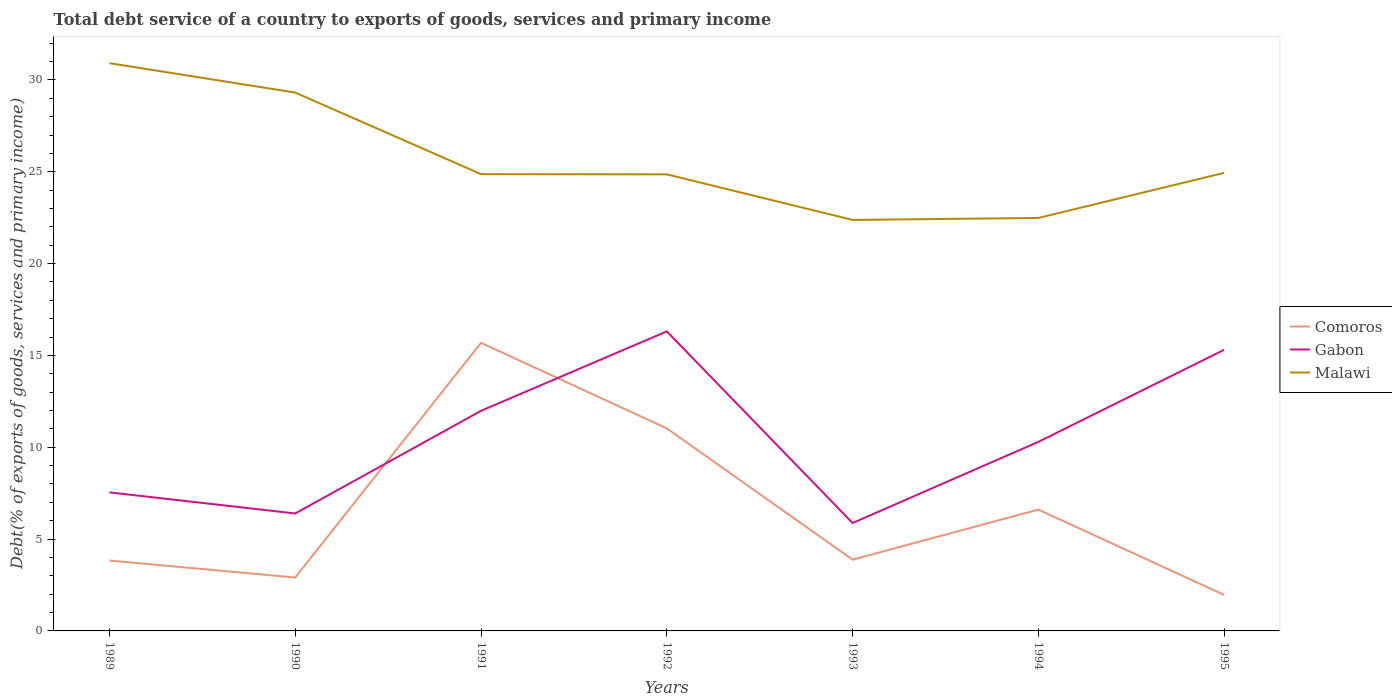Does the line corresponding to Gabon intersect with the line corresponding to Comoros?
Your response must be concise. Yes. Across all years, what is the maximum total debt service in Malawi?
Make the answer very short. 22.38. What is the total total debt service in Malawi in the graph?
Offer a terse response. 6.83. What is the difference between the highest and the second highest total debt service in Malawi?
Offer a very short reply. 8.54. Is the total debt service in Gabon strictly greater than the total debt service in Malawi over the years?
Provide a succinct answer. Yes. How many years are there in the graph?
Your response must be concise. 7. What is the difference between two consecutive major ticks on the Y-axis?
Ensure brevity in your answer.  5. Are the values on the major ticks of Y-axis written in scientific E-notation?
Ensure brevity in your answer.  No. Where does the legend appear in the graph?
Provide a short and direct response. Center right. What is the title of the graph?
Your answer should be very brief. Total debt service of a country to exports of goods, services and primary income. What is the label or title of the X-axis?
Offer a terse response. Years. What is the label or title of the Y-axis?
Your response must be concise. Debt(% of exports of goods, services and primary income). What is the Debt(% of exports of goods, services and primary income) in Comoros in 1989?
Give a very brief answer. 3.83. What is the Debt(% of exports of goods, services and primary income) of Gabon in 1989?
Ensure brevity in your answer.  7.54. What is the Debt(% of exports of goods, services and primary income) in Malawi in 1989?
Your answer should be very brief. 30.91. What is the Debt(% of exports of goods, services and primary income) in Comoros in 1990?
Your answer should be very brief. 2.91. What is the Debt(% of exports of goods, services and primary income) in Gabon in 1990?
Keep it short and to the point. 6.39. What is the Debt(% of exports of goods, services and primary income) in Malawi in 1990?
Provide a succinct answer. 29.31. What is the Debt(% of exports of goods, services and primary income) in Comoros in 1991?
Keep it short and to the point. 15.69. What is the Debt(% of exports of goods, services and primary income) of Gabon in 1991?
Keep it short and to the point. 11.98. What is the Debt(% of exports of goods, services and primary income) in Malawi in 1991?
Make the answer very short. 24.87. What is the Debt(% of exports of goods, services and primary income) of Comoros in 1992?
Your answer should be very brief. 11.03. What is the Debt(% of exports of goods, services and primary income) in Gabon in 1992?
Your answer should be very brief. 16.31. What is the Debt(% of exports of goods, services and primary income) of Malawi in 1992?
Provide a succinct answer. 24.86. What is the Debt(% of exports of goods, services and primary income) in Comoros in 1993?
Provide a succinct answer. 3.88. What is the Debt(% of exports of goods, services and primary income) of Gabon in 1993?
Your answer should be compact. 5.87. What is the Debt(% of exports of goods, services and primary income) in Malawi in 1993?
Offer a very short reply. 22.38. What is the Debt(% of exports of goods, services and primary income) of Comoros in 1994?
Provide a short and direct response. 6.61. What is the Debt(% of exports of goods, services and primary income) of Gabon in 1994?
Your answer should be compact. 10.29. What is the Debt(% of exports of goods, services and primary income) of Malawi in 1994?
Ensure brevity in your answer.  22.49. What is the Debt(% of exports of goods, services and primary income) in Comoros in 1995?
Your answer should be compact. 1.96. What is the Debt(% of exports of goods, services and primary income) in Gabon in 1995?
Ensure brevity in your answer.  15.31. What is the Debt(% of exports of goods, services and primary income) in Malawi in 1995?
Your response must be concise. 24.94. Across all years, what is the maximum Debt(% of exports of goods, services and primary income) in Comoros?
Give a very brief answer. 15.69. Across all years, what is the maximum Debt(% of exports of goods, services and primary income) of Gabon?
Ensure brevity in your answer.  16.31. Across all years, what is the maximum Debt(% of exports of goods, services and primary income) of Malawi?
Keep it short and to the point. 30.91. Across all years, what is the minimum Debt(% of exports of goods, services and primary income) in Comoros?
Provide a succinct answer. 1.96. Across all years, what is the minimum Debt(% of exports of goods, services and primary income) of Gabon?
Your answer should be compact. 5.87. Across all years, what is the minimum Debt(% of exports of goods, services and primary income) of Malawi?
Offer a very short reply. 22.38. What is the total Debt(% of exports of goods, services and primary income) in Comoros in the graph?
Your response must be concise. 45.9. What is the total Debt(% of exports of goods, services and primary income) in Gabon in the graph?
Ensure brevity in your answer.  73.71. What is the total Debt(% of exports of goods, services and primary income) of Malawi in the graph?
Provide a succinct answer. 179.76. What is the difference between the Debt(% of exports of goods, services and primary income) of Comoros in 1989 and that in 1990?
Offer a very short reply. 0.93. What is the difference between the Debt(% of exports of goods, services and primary income) in Gabon in 1989 and that in 1990?
Provide a succinct answer. 1.15. What is the difference between the Debt(% of exports of goods, services and primary income) of Malawi in 1989 and that in 1990?
Ensure brevity in your answer.  1.6. What is the difference between the Debt(% of exports of goods, services and primary income) of Comoros in 1989 and that in 1991?
Your answer should be compact. -11.85. What is the difference between the Debt(% of exports of goods, services and primary income) of Gabon in 1989 and that in 1991?
Your response must be concise. -4.44. What is the difference between the Debt(% of exports of goods, services and primary income) in Malawi in 1989 and that in 1991?
Your response must be concise. 6.04. What is the difference between the Debt(% of exports of goods, services and primary income) of Comoros in 1989 and that in 1992?
Offer a very short reply. -7.2. What is the difference between the Debt(% of exports of goods, services and primary income) of Gabon in 1989 and that in 1992?
Your answer should be very brief. -8.77. What is the difference between the Debt(% of exports of goods, services and primary income) of Malawi in 1989 and that in 1992?
Make the answer very short. 6.05. What is the difference between the Debt(% of exports of goods, services and primary income) of Comoros in 1989 and that in 1993?
Your response must be concise. -0.05. What is the difference between the Debt(% of exports of goods, services and primary income) of Gabon in 1989 and that in 1993?
Keep it short and to the point. 1.67. What is the difference between the Debt(% of exports of goods, services and primary income) of Malawi in 1989 and that in 1993?
Keep it short and to the point. 8.54. What is the difference between the Debt(% of exports of goods, services and primary income) of Comoros in 1989 and that in 1994?
Provide a short and direct response. -2.77. What is the difference between the Debt(% of exports of goods, services and primary income) of Gabon in 1989 and that in 1994?
Provide a succinct answer. -2.75. What is the difference between the Debt(% of exports of goods, services and primary income) of Malawi in 1989 and that in 1994?
Provide a succinct answer. 8.43. What is the difference between the Debt(% of exports of goods, services and primary income) in Comoros in 1989 and that in 1995?
Give a very brief answer. 1.87. What is the difference between the Debt(% of exports of goods, services and primary income) in Gabon in 1989 and that in 1995?
Make the answer very short. -7.76. What is the difference between the Debt(% of exports of goods, services and primary income) of Malawi in 1989 and that in 1995?
Keep it short and to the point. 5.97. What is the difference between the Debt(% of exports of goods, services and primary income) of Comoros in 1990 and that in 1991?
Keep it short and to the point. -12.78. What is the difference between the Debt(% of exports of goods, services and primary income) of Gabon in 1990 and that in 1991?
Ensure brevity in your answer.  -5.59. What is the difference between the Debt(% of exports of goods, services and primary income) of Malawi in 1990 and that in 1991?
Offer a very short reply. 4.44. What is the difference between the Debt(% of exports of goods, services and primary income) of Comoros in 1990 and that in 1992?
Your response must be concise. -8.12. What is the difference between the Debt(% of exports of goods, services and primary income) of Gabon in 1990 and that in 1992?
Your answer should be very brief. -9.92. What is the difference between the Debt(% of exports of goods, services and primary income) in Malawi in 1990 and that in 1992?
Give a very brief answer. 4.45. What is the difference between the Debt(% of exports of goods, services and primary income) in Comoros in 1990 and that in 1993?
Your answer should be compact. -0.97. What is the difference between the Debt(% of exports of goods, services and primary income) of Gabon in 1990 and that in 1993?
Your response must be concise. 0.52. What is the difference between the Debt(% of exports of goods, services and primary income) in Malawi in 1990 and that in 1993?
Offer a terse response. 6.93. What is the difference between the Debt(% of exports of goods, services and primary income) in Comoros in 1990 and that in 1994?
Provide a short and direct response. -3.7. What is the difference between the Debt(% of exports of goods, services and primary income) of Gabon in 1990 and that in 1994?
Your answer should be compact. -3.9. What is the difference between the Debt(% of exports of goods, services and primary income) in Malawi in 1990 and that in 1994?
Give a very brief answer. 6.83. What is the difference between the Debt(% of exports of goods, services and primary income) in Comoros in 1990 and that in 1995?
Provide a short and direct response. 0.95. What is the difference between the Debt(% of exports of goods, services and primary income) in Gabon in 1990 and that in 1995?
Give a very brief answer. -8.91. What is the difference between the Debt(% of exports of goods, services and primary income) of Malawi in 1990 and that in 1995?
Give a very brief answer. 4.37. What is the difference between the Debt(% of exports of goods, services and primary income) in Comoros in 1991 and that in 1992?
Provide a short and direct response. 4.66. What is the difference between the Debt(% of exports of goods, services and primary income) of Gabon in 1991 and that in 1992?
Provide a succinct answer. -4.33. What is the difference between the Debt(% of exports of goods, services and primary income) in Malawi in 1991 and that in 1992?
Provide a succinct answer. 0.01. What is the difference between the Debt(% of exports of goods, services and primary income) in Comoros in 1991 and that in 1993?
Your response must be concise. 11.81. What is the difference between the Debt(% of exports of goods, services and primary income) in Gabon in 1991 and that in 1993?
Your response must be concise. 6.11. What is the difference between the Debt(% of exports of goods, services and primary income) of Malawi in 1991 and that in 1993?
Offer a very short reply. 2.49. What is the difference between the Debt(% of exports of goods, services and primary income) of Comoros in 1991 and that in 1994?
Your answer should be compact. 9.08. What is the difference between the Debt(% of exports of goods, services and primary income) in Gabon in 1991 and that in 1994?
Your answer should be very brief. 1.69. What is the difference between the Debt(% of exports of goods, services and primary income) in Malawi in 1991 and that in 1994?
Make the answer very short. 2.39. What is the difference between the Debt(% of exports of goods, services and primary income) in Comoros in 1991 and that in 1995?
Give a very brief answer. 13.73. What is the difference between the Debt(% of exports of goods, services and primary income) in Gabon in 1991 and that in 1995?
Your answer should be compact. -3.32. What is the difference between the Debt(% of exports of goods, services and primary income) in Malawi in 1991 and that in 1995?
Offer a very short reply. -0.07. What is the difference between the Debt(% of exports of goods, services and primary income) in Comoros in 1992 and that in 1993?
Your answer should be compact. 7.15. What is the difference between the Debt(% of exports of goods, services and primary income) of Gabon in 1992 and that in 1993?
Offer a terse response. 10.44. What is the difference between the Debt(% of exports of goods, services and primary income) in Malawi in 1992 and that in 1993?
Provide a succinct answer. 2.48. What is the difference between the Debt(% of exports of goods, services and primary income) in Comoros in 1992 and that in 1994?
Ensure brevity in your answer.  4.42. What is the difference between the Debt(% of exports of goods, services and primary income) of Gabon in 1992 and that in 1994?
Provide a succinct answer. 6.02. What is the difference between the Debt(% of exports of goods, services and primary income) of Malawi in 1992 and that in 1994?
Your answer should be compact. 2.37. What is the difference between the Debt(% of exports of goods, services and primary income) in Comoros in 1992 and that in 1995?
Provide a succinct answer. 9.07. What is the difference between the Debt(% of exports of goods, services and primary income) of Malawi in 1992 and that in 1995?
Provide a succinct answer. -0.08. What is the difference between the Debt(% of exports of goods, services and primary income) in Comoros in 1993 and that in 1994?
Your answer should be compact. -2.73. What is the difference between the Debt(% of exports of goods, services and primary income) of Gabon in 1993 and that in 1994?
Your response must be concise. -4.42. What is the difference between the Debt(% of exports of goods, services and primary income) in Malawi in 1993 and that in 1994?
Your answer should be very brief. -0.11. What is the difference between the Debt(% of exports of goods, services and primary income) in Comoros in 1993 and that in 1995?
Your response must be concise. 1.92. What is the difference between the Debt(% of exports of goods, services and primary income) in Gabon in 1993 and that in 1995?
Provide a short and direct response. -9.43. What is the difference between the Debt(% of exports of goods, services and primary income) in Malawi in 1993 and that in 1995?
Your answer should be compact. -2.56. What is the difference between the Debt(% of exports of goods, services and primary income) of Comoros in 1994 and that in 1995?
Give a very brief answer. 4.65. What is the difference between the Debt(% of exports of goods, services and primary income) of Gabon in 1994 and that in 1995?
Make the answer very short. -5.01. What is the difference between the Debt(% of exports of goods, services and primary income) in Malawi in 1994 and that in 1995?
Make the answer very short. -2.45. What is the difference between the Debt(% of exports of goods, services and primary income) in Comoros in 1989 and the Debt(% of exports of goods, services and primary income) in Gabon in 1990?
Your answer should be compact. -2.56. What is the difference between the Debt(% of exports of goods, services and primary income) of Comoros in 1989 and the Debt(% of exports of goods, services and primary income) of Malawi in 1990?
Provide a succinct answer. -25.48. What is the difference between the Debt(% of exports of goods, services and primary income) of Gabon in 1989 and the Debt(% of exports of goods, services and primary income) of Malawi in 1990?
Offer a terse response. -21.77. What is the difference between the Debt(% of exports of goods, services and primary income) of Comoros in 1989 and the Debt(% of exports of goods, services and primary income) of Gabon in 1991?
Provide a succinct answer. -8.15. What is the difference between the Debt(% of exports of goods, services and primary income) of Comoros in 1989 and the Debt(% of exports of goods, services and primary income) of Malawi in 1991?
Offer a terse response. -21.04. What is the difference between the Debt(% of exports of goods, services and primary income) in Gabon in 1989 and the Debt(% of exports of goods, services and primary income) in Malawi in 1991?
Provide a succinct answer. -17.33. What is the difference between the Debt(% of exports of goods, services and primary income) of Comoros in 1989 and the Debt(% of exports of goods, services and primary income) of Gabon in 1992?
Ensure brevity in your answer.  -12.48. What is the difference between the Debt(% of exports of goods, services and primary income) in Comoros in 1989 and the Debt(% of exports of goods, services and primary income) in Malawi in 1992?
Your answer should be compact. -21.03. What is the difference between the Debt(% of exports of goods, services and primary income) in Gabon in 1989 and the Debt(% of exports of goods, services and primary income) in Malawi in 1992?
Provide a succinct answer. -17.32. What is the difference between the Debt(% of exports of goods, services and primary income) of Comoros in 1989 and the Debt(% of exports of goods, services and primary income) of Gabon in 1993?
Make the answer very short. -2.04. What is the difference between the Debt(% of exports of goods, services and primary income) of Comoros in 1989 and the Debt(% of exports of goods, services and primary income) of Malawi in 1993?
Make the answer very short. -18.55. What is the difference between the Debt(% of exports of goods, services and primary income) of Gabon in 1989 and the Debt(% of exports of goods, services and primary income) of Malawi in 1993?
Ensure brevity in your answer.  -14.83. What is the difference between the Debt(% of exports of goods, services and primary income) in Comoros in 1989 and the Debt(% of exports of goods, services and primary income) in Gabon in 1994?
Provide a succinct answer. -6.46. What is the difference between the Debt(% of exports of goods, services and primary income) of Comoros in 1989 and the Debt(% of exports of goods, services and primary income) of Malawi in 1994?
Keep it short and to the point. -18.65. What is the difference between the Debt(% of exports of goods, services and primary income) in Gabon in 1989 and the Debt(% of exports of goods, services and primary income) in Malawi in 1994?
Your answer should be compact. -14.94. What is the difference between the Debt(% of exports of goods, services and primary income) in Comoros in 1989 and the Debt(% of exports of goods, services and primary income) in Gabon in 1995?
Provide a short and direct response. -11.48. What is the difference between the Debt(% of exports of goods, services and primary income) of Comoros in 1989 and the Debt(% of exports of goods, services and primary income) of Malawi in 1995?
Keep it short and to the point. -21.11. What is the difference between the Debt(% of exports of goods, services and primary income) of Gabon in 1989 and the Debt(% of exports of goods, services and primary income) of Malawi in 1995?
Make the answer very short. -17.4. What is the difference between the Debt(% of exports of goods, services and primary income) of Comoros in 1990 and the Debt(% of exports of goods, services and primary income) of Gabon in 1991?
Your answer should be very brief. -9.08. What is the difference between the Debt(% of exports of goods, services and primary income) of Comoros in 1990 and the Debt(% of exports of goods, services and primary income) of Malawi in 1991?
Your answer should be compact. -21.96. What is the difference between the Debt(% of exports of goods, services and primary income) in Gabon in 1990 and the Debt(% of exports of goods, services and primary income) in Malawi in 1991?
Give a very brief answer. -18.48. What is the difference between the Debt(% of exports of goods, services and primary income) in Comoros in 1990 and the Debt(% of exports of goods, services and primary income) in Gabon in 1992?
Offer a terse response. -13.4. What is the difference between the Debt(% of exports of goods, services and primary income) in Comoros in 1990 and the Debt(% of exports of goods, services and primary income) in Malawi in 1992?
Offer a very short reply. -21.95. What is the difference between the Debt(% of exports of goods, services and primary income) of Gabon in 1990 and the Debt(% of exports of goods, services and primary income) of Malawi in 1992?
Provide a succinct answer. -18.46. What is the difference between the Debt(% of exports of goods, services and primary income) of Comoros in 1990 and the Debt(% of exports of goods, services and primary income) of Gabon in 1993?
Provide a short and direct response. -2.97. What is the difference between the Debt(% of exports of goods, services and primary income) of Comoros in 1990 and the Debt(% of exports of goods, services and primary income) of Malawi in 1993?
Provide a succinct answer. -19.47. What is the difference between the Debt(% of exports of goods, services and primary income) in Gabon in 1990 and the Debt(% of exports of goods, services and primary income) in Malawi in 1993?
Provide a short and direct response. -15.98. What is the difference between the Debt(% of exports of goods, services and primary income) in Comoros in 1990 and the Debt(% of exports of goods, services and primary income) in Gabon in 1994?
Your response must be concise. -7.39. What is the difference between the Debt(% of exports of goods, services and primary income) of Comoros in 1990 and the Debt(% of exports of goods, services and primary income) of Malawi in 1994?
Ensure brevity in your answer.  -19.58. What is the difference between the Debt(% of exports of goods, services and primary income) of Gabon in 1990 and the Debt(% of exports of goods, services and primary income) of Malawi in 1994?
Your answer should be compact. -16.09. What is the difference between the Debt(% of exports of goods, services and primary income) in Comoros in 1990 and the Debt(% of exports of goods, services and primary income) in Gabon in 1995?
Your answer should be very brief. -12.4. What is the difference between the Debt(% of exports of goods, services and primary income) in Comoros in 1990 and the Debt(% of exports of goods, services and primary income) in Malawi in 1995?
Provide a short and direct response. -22.03. What is the difference between the Debt(% of exports of goods, services and primary income) in Gabon in 1990 and the Debt(% of exports of goods, services and primary income) in Malawi in 1995?
Your answer should be very brief. -18.55. What is the difference between the Debt(% of exports of goods, services and primary income) of Comoros in 1991 and the Debt(% of exports of goods, services and primary income) of Gabon in 1992?
Your answer should be very brief. -0.62. What is the difference between the Debt(% of exports of goods, services and primary income) of Comoros in 1991 and the Debt(% of exports of goods, services and primary income) of Malawi in 1992?
Keep it short and to the point. -9.17. What is the difference between the Debt(% of exports of goods, services and primary income) in Gabon in 1991 and the Debt(% of exports of goods, services and primary income) in Malawi in 1992?
Ensure brevity in your answer.  -12.88. What is the difference between the Debt(% of exports of goods, services and primary income) of Comoros in 1991 and the Debt(% of exports of goods, services and primary income) of Gabon in 1993?
Keep it short and to the point. 9.81. What is the difference between the Debt(% of exports of goods, services and primary income) of Comoros in 1991 and the Debt(% of exports of goods, services and primary income) of Malawi in 1993?
Offer a terse response. -6.69. What is the difference between the Debt(% of exports of goods, services and primary income) in Gabon in 1991 and the Debt(% of exports of goods, services and primary income) in Malawi in 1993?
Provide a succinct answer. -10.39. What is the difference between the Debt(% of exports of goods, services and primary income) in Comoros in 1991 and the Debt(% of exports of goods, services and primary income) in Gabon in 1994?
Offer a very short reply. 5.39. What is the difference between the Debt(% of exports of goods, services and primary income) in Comoros in 1991 and the Debt(% of exports of goods, services and primary income) in Malawi in 1994?
Give a very brief answer. -6.8. What is the difference between the Debt(% of exports of goods, services and primary income) of Gabon in 1991 and the Debt(% of exports of goods, services and primary income) of Malawi in 1994?
Offer a terse response. -10.5. What is the difference between the Debt(% of exports of goods, services and primary income) in Comoros in 1991 and the Debt(% of exports of goods, services and primary income) in Gabon in 1995?
Offer a terse response. 0.38. What is the difference between the Debt(% of exports of goods, services and primary income) of Comoros in 1991 and the Debt(% of exports of goods, services and primary income) of Malawi in 1995?
Offer a terse response. -9.25. What is the difference between the Debt(% of exports of goods, services and primary income) in Gabon in 1991 and the Debt(% of exports of goods, services and primary income) in Malawi in 1995?
Ensure brevity in your answer.  -12.96. What is the difference between the Debt(% of exports of goods, services and primary income) in Comoros in 1992 and the Debt(% of exports of goods, services and primary income) in Gabon in 1993?
Offer a very short reply. 5.15. What is the difference between the Debt(% of exports of goods, services and primary income) of Comoros in 1992 and the Debt(% of exports of goods, services and primary income) of Malawi in 1993?
Make the answer very short. -11.35. What is the difference between the Debt(% of exports of goods, services and primary income) of Gabon in 1992 and the Debt(% of exports of goods, services and primary income) of Malawi in 1993?
Your response must be concise. -6.07. What is the difference between the Debt(% of exports of goods, services and primary income) in Comoros in 1992 and the Debt(% of exports of goods, services and primary income) in Gabon in 1994?
Ensure brevity in your answer.  0.73. What is the difference between the Debt(% of exports of goods, services and primary income) of Comoros in 1992 and the Debt(% of exports of goods, services and primary income) of Malawi in 1994?
Provide a short and direct response. -11.46. What is the difference between the Debt(% of exports of goods, services and primary income) in Gabon in 1992 and the Debt(% of exports of goods, services and primary income) in Malawi in 1994?
Provide a short and direct response. -6.18. What is the difference between the Debt(% of exports of goods, services and primary income) of Comoros in 1992 and the Debt(% of exports of goods, services and primary income) of Gabon in 1995?
Offer a terse response. -4.28. What is the difference between the Debt(% of exports of goods, services and primary income) of Comoros in 1992 and the Debt(% of exports of goods, services and primary income) of Malawi in 1995?
Provide a succinct answer. -13.91. What is the difference between the Debt(% of exports of goods, services and primary income) in Gabon in 1992 and the Debt(% of exports of goods, services and primary income) in Malawi in 1995?
Offer a very short reply. -8.63. What is the difference between the Debt(% of exports of goods, services and primary income) in Comoros in 1993 and the Debt(% of exports of goods, services and primary income) in Gabon in 1994?
Provide a succinct answer. -6.41. What is the difference between the Debt(% of exports of goods, services and primary income) in Comoros in 1993 and the Debt(% of exports of goods, services and primary income) in Malawi in 1994?
Your answer should be compact. -18.6. What is the difference between the Debt(% of exports of goods, services and primary income) of Gabon in 1993 and the Debt(% of exports of goods, services and primary income) of Malawi in 1994?
Give a very brief answer. -16.61. What is the difference between the Debt(% of exports of goods, services and primary income) in Comoros in 1993 and the Debt(% of exports of goods, services and primary income) in Gabon in 1995?
Offer a terse response. -11.43. What is the difference between the Debt(% of exports of goods, services and primary income) in Comoros in 1993 and the Debt(% of exports of goods, services and primary income) in Malawi in 1995?
Give a very brief answer. -21.06. What is the difference between the Debt(% of exports of goods, services and primary income) of Gabon in 1993 and the Debt(% of exports of goods, services and primary income) of Malawi in 1995?
Offer a very short reply. -19.06. What is the difference between the Debt(% of exports of goods, services and primary income) of Comoros in 1994 and the Debt(% of exports of goods, services and primary income) of Gabon in 1995?
Your response must be concise. -8.7. What is the difference between the Debt(% of exports of goods, services and primary income) in Comoros in 1994 and the Debt(% of exports of goods, services and primary income) in Malawi in 1995?
Provide a short and direct response. -18.33. What is the difference between the Debt(% of exports of goods, services and primary income) of Gabon in 1994 and the Debt(% of exports of goods, services and primary income) of Malawi in 1995?
Make the answer very short. -14.64. What is the average Debt(% of exports of goods, services and primary income) of Comoros per year?
Make the answer very short. 6.56. What is the average Debt(% of exports of goods, services and primary income) of Gabon per year?
Offer a very short reply. 10.53. What is the average Debt(% of exports of goods, services and primary income) of Malawi per year?
Provide a succinct answer. 25.68. In the year 1989, what is the difference between the Debt(% of exports of goods, services and primary income) in Comoros and Debt(% of exports of goods, services and primary income) in Gabon?
Ensure brevity in your answer.  -3.71. In the year 1989, what is the difference between the Debt(% of exports of goods, services and primary income) in Comoros and Debt(% of exports of goods, services and primary income) in Malawi?
Your answer should be compact. -27.08. In the year 1989, what is the difference between the Debt(% of exports of goods, services and primary income) of Gabon and Debt(% of exports of goods, services and primary income) of Malawi?
Your response must be concise. -23.37. In the year 1990, what is the difference between the Debt(% of exports of goods, services and primary income) of Comoros and Debt(% of exports of goods, services and primary income) of Gabon?
Provide a succinct answer. -3.49. In the year 1990, what is the difference between the Debt(% of exports of goods, services and primary income) in Comoros and Debt(% of exports of goods, services and primary income) in Malawi?
Your answer should be compact. -26.41. In the year 1990, what is the difference between the Debt(% of exports of goods, services and primary income) in Gabon and Debt(% of exports of goods, services and primary income) in Malawi?
Ensure brevity in your answer.  -22.92. In the year 1991, what is the difference between the Debt(% of exports of goods, services and primary income) in Comoros and Debt(% of exports of goods, services and primary income) in Gabon?
Give a very brief answer. 3.7. In the year 1991, what is the difference between the Debt(% of exports of goods, services and primary income) in Comoros and Debt(% of exports of goods, services and primary income) in Malawi?
Ensure brevity in your answer.  -9.18. In the year 1991, what is the difference between the Debt(% of exports of goods, services and primary income) in Gabon and Debt(% of exports of goods, services and primary income) in Malawi?
Provide a succinct answer. -12.89. In the year 1992, what is the difference between the Debt(% of exports of goods, services and primary income) of Comoros and Debt(% of exports of goods, services and primary income) of Gabon?
Your response must be concise. -5.28. In the year 1992, what is the difference between the Debt(% of exports of goods, services and primary income) in Comoros and Debt(% of exports of goods, services and primary income) in Malawi?
Offer a terse response. -13.83. In the year 1992, what is the difference between the Debt(% of exports of goods, services and primary income) in Gabon and Debt(% of exports of goods, services and primary income) in Malawi?
Ensure brevity in your answer.  -8.55. In the year 1993, what is the difference between the Debt(% of exports of goods, services and primary income) of Comoros and Debt(% of exports of goods, services and primary income) of Gabon?
Your response must be concise. -1.99. In the year 1993, what is the difference between the Debt(% of exports of goods, services and primary income) of Comoros and Debt(% of exports of goods, services and primary income) of Malawi?
Provide a succinct answer. -18.5. In the year 1993, what is the difference between the Debt(% of exports of goods, services and primary income) in Gabon and Debt(% of exports of goods, services and primary income) in Malawi?
Your answer should be compact. -16.5. In the year 1994, what is the difference between the Debt(% of exports of goods, services and primary income) in Comoros and Debt(% of exports of goods, services and primary income) in Gabon?
Offer a terse response. -3.69. In the year 1994, what is the difference between the Debt(% of exports of goods, services and primary income) in Comoros and Debt(% of exports of goods, services and primary income) in Malawi?
Keep it short and to the point. -15.88. In the year 1994, what is the difference between the Debt(% of exports of goods, services and primary income) in Gabon and Debt(% of exports of goods, services and primary income) in Malawi?
Offer a terse response. -12.19. In the year 1995, what is the difference between the Debt(% of exports of goods, services and primary income) of Comoros and Debt(% of exports of goods, services and primary income) of Gabon?
Make the answer very short. -13.35. In the year 1995, what is the difference between the Debt(% of exports of goods, services and primary income) in Comoros and Debt(% of exports of goods, services and primary income) in Malawi?
Ensure brevity in your answer.  -22.98. In the year 1995, what is the difference between the Debt(% of exports of goods, services and primary income) in Gabon and Debt(% of exports of goods, services and primary income) in Malawi?
Give a very brief answer. -9.63. What is the ratio of the Debt(% of exports of goods, services and primary income) in Comoros in 1989 to that in 1990?
Offer a terse response. 1.32. What is the ratio of the Debt(% of exports of goods, services and primary income) in Gabon in 1989 to that in 1990?
Your response must be concise. 1.18. What is the ratio of the Debt(% of exports of goods, services and primary income) in Malawi in 1989 to that in 1990?
Offer a terse response. 1.05. What is the ratio of the Debt(% of exports of goods, services and primary income) of Comoros in 1989 to that in 1991?
Keep it short and to the point. 0.24. What is the ratio of the Debt(% of exports of goods, services and primary income) of Gabon in 1989 to that in 1991?
Offer a terse response. 0.63. What is the ratio of the Debt(% of exports of goods, services and primary income) in Malawi in 1989 to that in 1991?
Offer a very short reply. 1.24. What is the ratio of the Debt(% of exports of goods, services and primary income) in Comoros in 1989 to that in 1992?
Offer a very short reply. 0.35. What is the ratio of the Debt(% of exports of goods, services and primary income) of Gabon in 1989 to that in 1992?
Keep it short and to the point. 0.46. What is the ratio of the Debt(% of exports of goods, services and primary income) in Malawi in 1989 to that in 1992?
Keep it short and to the point. 1.24. What is the ratio of the Debt(% of exports of goods, services and primary income) of Comoros in 1989 to that in 1993?
Offer a very short reply. 0.99. What is the ratio of the Debt(% of exports of goods, services and primary income) of Gabon in 1989 to that in 1993?
Keep it short and to the point. 1.28. What is the ratio of the Debt(% of exports of goods, services and primary income) in Malawi in 1989 to that in 1993?
Provide a short and direct response. 1.38. What is the ratio of the Debt(% of exports of goods, services and primary income) of Comoros in 1989 to that in 1994?
Offer a terse response. 0.58. What is the ratio of the Debt(% of exports of goods, services and primary income) in Gabon in 1989 to that in 1994?
Offer a terse response. 0.73. What is the ratio of the Debt(% of exports of goods, services and primary income) in Malawi in 1989 to that in 1994?
Provide a succinct answer. 1.37. What is the ratio of the Debt(% of exports of goods, services and primary income) of Comoros in 1989 to that in 1995?
Your response must be concise. 1.96. What is the ratio of the Debt(% of exports of goods, services and primary income) of Gabon in 1989 to that in 1995?
Your answer should be very brief. 0.49. What is the ratio of the Debt(% of exports of goods, services and primary income) of Malawi in 1989 to that in 1995?
Make the answer very short. 1.24. What is the ratio of the Debt(% of exports of goods, services and primary income) of Comoros in 1990 to that in 1991?
Your answer should be compact. 0.19. What is the ratio of the Debt(% of exports of goods, services and primary income) of Gabon in 1990 to that in 1991?
Your response must be concise. 0.53. What is the ratio of the Debt(% of exports of goods, services and primary income) in Malawi in 1990 to that in 1991?
Ensure brevity in your answer.  1.18. What is the ratio of the Debt(% of exports of goods, services and primary income) in Comoros in 1990 to that in 1992?
Keep it short and to the point. 0.26. What is the ratio of the Debt(% of exports of goods, services and primary income) of Gabon in 1990 to that in 1992?
Your answer should be very brief. 0.39. What is the ratio of the Debt(% of exports of goods, services and primary income) of Malawi in 1990 to that in 1992?
Offer a terse response. 1.18. What is the ratio of the Debt(% of exports of goods, services and primary income) of Comoros in 1990 to that in 1993?
Keep it short and to the point. 0.75. What is the ratio of the Debt(% of exports of goods, services and primary income) of Gabon in 1990 to that in 1993?
Provide a succinct answer. 1.09. What is the ratio of the Debt(% of exports of goods, services and primary income) of Malawi in 1990 to that in 1993?
Your response must be concise. 1.31. What is the ratio of the Debt(% of exports of goods, services and primary income) of Comoros in 1990 to that in 1994?
Your answer should be very brief. 0.44. What is the ratio of the Debt(% of exports of goods, services and primary income) in Gabon in 1990 to that in 1994?
Provide a short and direct response. 0.62. What is the ratio of the Debt(% of exports of goods, services and primary income) in Malawi in 1990 to that in 1994?
Provide a short and direct response. 1.3. What is the ratio of the Debt(% of exports of goods, services and primary income) of Comoros in 1990 to that in 1995?
Offer a terse response. 1.48. What is the ratio of the Debt(% of exports of goods, services and primary income) in Gabon in 1990 to that in 1995?
Offer a terse response. 0.42. What is the ratio of the Debt(% of exports of goods, services and primary income) of Malawi in 1990 to that in 1995?
Offer a very short reply. 1.18. What is the ratio of the Debt(% of exports of goods, services and primary income) of Comoros in 1991 to that in 1992?
Make the answer very short. 1.42. What is the ratio of the Debt(% of exports of goods, services and primary income) of Gabon in 1991 to that in 1992?
Provide a succinct answer. 0.73. What is the ratio of the Debt(% of exports of goods, services and primary income) in Comoros in 1991 to that in 1993?
Offer a terse response. 4.04. What is the ratio of the Debt(% of exports of goods, services and primary income) of Gabon in 1991 to that in 1993?
Your answer should be very brief. 2.04. What is the ratio of the Debt(% of exports of goods, services and primary income) of Malawi in 1991 to that in 1993?
Your answer should be compact. 1.11. What is the ratio of the Debt(% of exports of goods, services and primary income) in Comoros in 1991 to that in 1994?
Offer a very short reply. 2.37. What is the ratio of the Debt(% of exports of goods, services and primary income) of Gabon in 1991 to that in 1994?
Give a very brief answer. 1.16. What is the ratio of the Debt(% of exports of goods, services and primary income) of Malawi in 1991 to that in 1994?
Make the answer very short. 1.11. What is the ratio of the Debt(% of exports of goods, services and primary income) in Comoros in 1991 to that in 1995?
Your response must be concise. 8. What is the ratio of the Debt(% of exports of goods, services and primary income) in Gabon in 1991 to that in 1995?
Offer a terse response. 0.78. What is the ratio of the Debt(% of exports of goods, services and primary income) of Malawi in 1991 to that in 1995?
Your response must be concise. 1. What is the ratio of the Debt(% of exports of goods, services and primary income) in Comoros in 1992 to that in 1993?
Ensure brevity in your answer.  2.84. What is the ratio of the Debt(% of exports of goods, services and primary income) in Gabon in 1992 to that in 1993?
Provide a succinct answer. 2.78. What is the ratio of the Debt(% of exports of goods, services and primary income) of Malawi in 1992 to that in 1993?
Your answer should be compact. 1.11. What is the ratio of the Debt(% of exports of goods, services and primary income) in Comoros in 1992 to that in 1994?
Offer a terse response. 1.67. What is the ratio of the Debt(% of exports of goods, services and primary income) of Gabon in 1992 to that in 1994?
Give a very brief answer. 1.58. What is the ratio of the Debt(% of exports of goods, services and primary income) of Malawi in 1992 to that in 1994?
Provide a succinct answer. 1.11. What is the ratio of the Debt(% of exports of goods, services and primary income) of Comoros in 1992 to that in 1995?
Ensure brevity in your answer.  5.63. What is the ratio of the Debt(% of exports of goods, services and primary income) of Gabon in 1992 to that in 1995?
Give a very brief answer. 1.07. What is the ratio of the Debt(% of exports of goods, services and primary income) of Malawi in 1992 to that in 1995?
Give a very brief answer. 1. What is the ratio of the Debt(% of exports of goods, services and primary income) of Comoros in 1993 to that in 1994?
Provide a short and direct response. 0.59. What is the ratio of the Debt(% of exports of goods, services and primary income) in Gabon in 1993 to that in 1994?
Offer a terse response. 0.57. What is the ratio of the Debt(% of exports of goods, services and primary income) in Comoros in 1993 to that in 1995?
Offer a terse response. 1.98. What is the ratio of the Debt(% of exports of goods, services and primary income) of Gabon in 1993 to that in 1995?
Your answer should be compact. 0.38. What is the ratio of the Debt(% of exports of goods, services and primary income) of Malawi in 1993 to that in 1995?
Keep it short and to the point. 0.9. What is the ratio of the Debt(% of exports of goods, services and primary income) of Comoros in 1994 to that in 1995?
Give a very brief answer. 3.37. What is the ratio of the Debt(% of exports of goods, services and primary income) in Gabon in 1994 to that in 1995?
Give a very brief answer. 0.67. What is the ratio of the Debt(% of exports of goods, services and primary income) of Malawi in 1994 to that in 1995?
Give a very brief answer. 0.9. What is the difference between the highest and the second highest Debt(% of exports of goods, services and primary income) of Comoros?
Offer a very short reply. 4.66. What is the difference between the highest and the second highest Debt(% of exports of goods, services and primary income) of Malawi?
Your answer should be very brief. 1.6. What is the difference between the highest and the lowest Debt(% of exports of goods, services and primary income) in Comoros?
Provide a succinct answer. 13.73. What is the difference between the highest and the lowest Debt(% of exports of goods, services and primary income) in Gabon?
Make the answer very short. 10.44. What is the difference between the highest and the lowest Debt(% of exports of goods, services and primary income) in Malawi?
Provide a short and direct response. 8.54. 